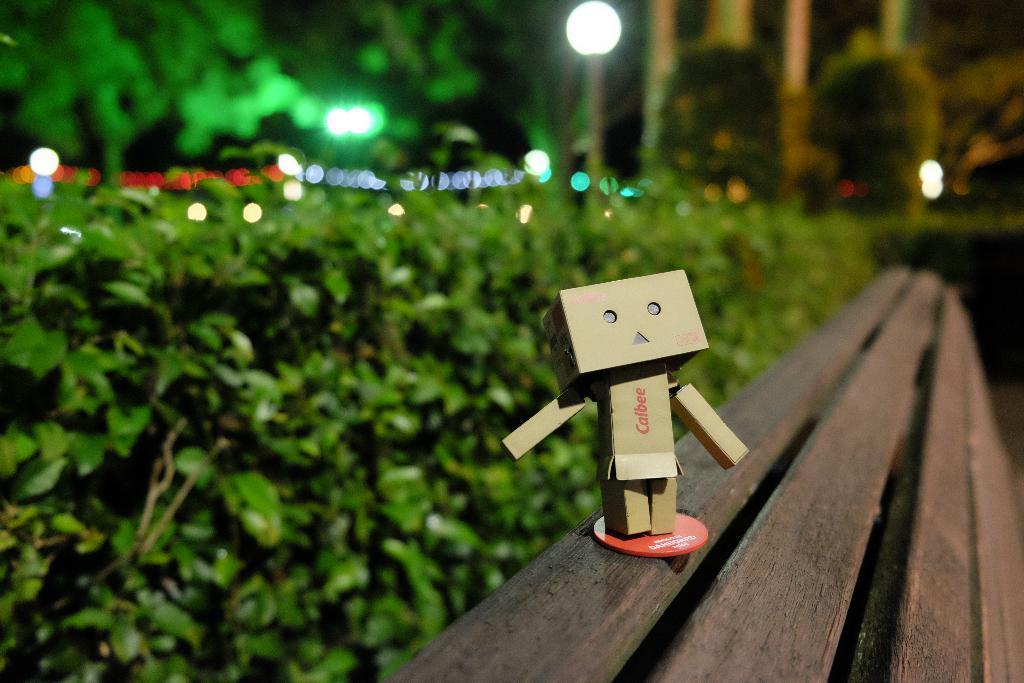Please provide a concise description of this image. In this image, we can see a wooden bench, there is toy on the bench, we can see some green plants and trees, we can see some lights. 